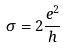Convert formula to latex. <formula><loc_0><loc_0><loc_500><loc_500>\sigma = 2 \frac { e ^ { 2 } } { h }</formula> 